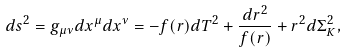Convert formula to latex. <formula><loc_0><loc_0><loc_500><loc_500>d s ^ { 2 } = g _ { \mu \nu } d x ^ { \mu } d x ^ { \nu } = - f ( r ) d T ^ { 2 } + \frac { d r ^ { 2 } } { f ( r ) } + r ^ { 2 } d \Sigma _ { K } ^ { 2 } ,</formula> 